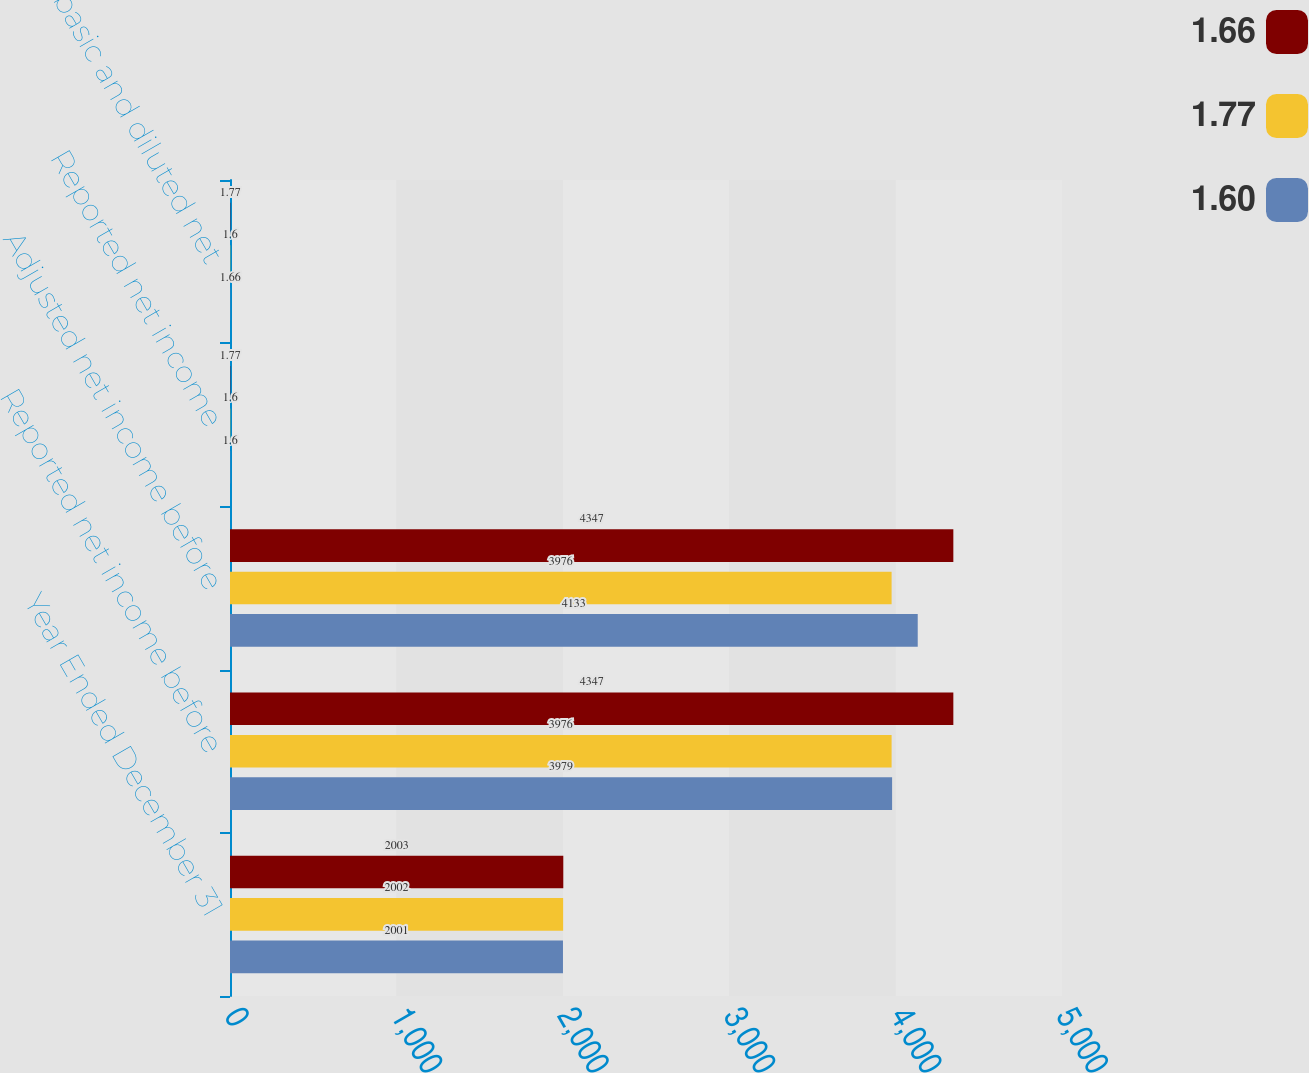Convert chart. <chart><loc_0><loc_0><loc_500><loc_500><stacked_bar_chart><ecel><fcel>Year Ended December 31<fcel>Reported net income before<fcel>Adjusted net income before<fcel>Reported net income<fcel>Adjusted basic and diluted net<nl><fcel>1.66<fcel>2003<fcel>4347<fcel>4347<fcel>1.77<fcel>1.77<nl><fcel>1.77<fcel>2002<fcel>3976<fcel>3976<fcel>1.6<fcel>1.6<nl><fcel>1.6<fcel>2001<fcel>3979<fcel>4133<fcel>1.6<fcel>1.66<nl></chart> 